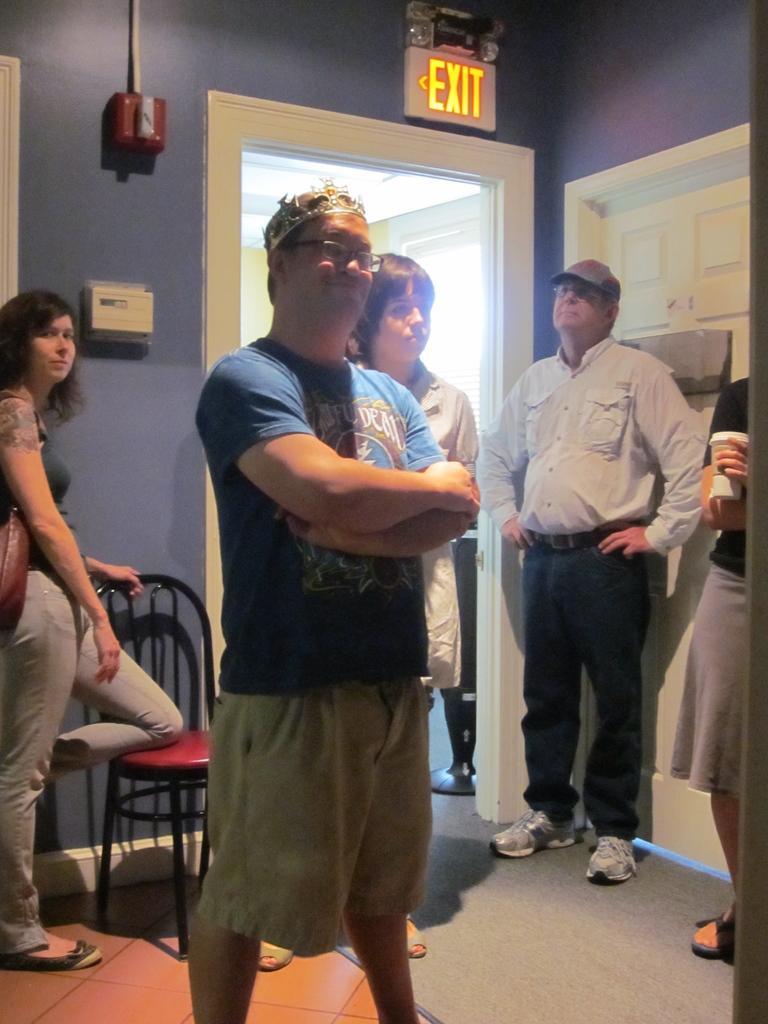In one or two sentences, can you explain what this image depicts? In this image there are group of people standing, there is a chair, door, exit board attached to the wall. 